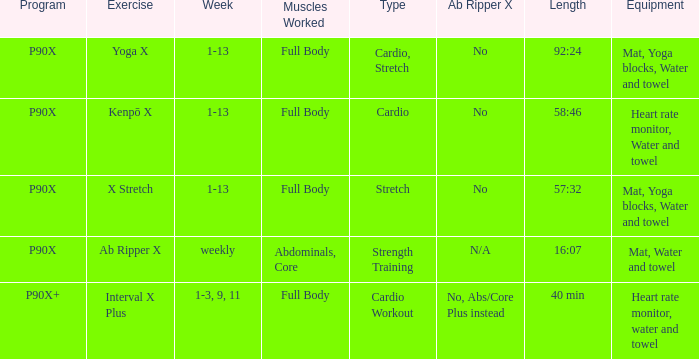What is the physical activity when the gear is heart rate monitor, water, and towel? Kenpō X, Interval X Plus. 